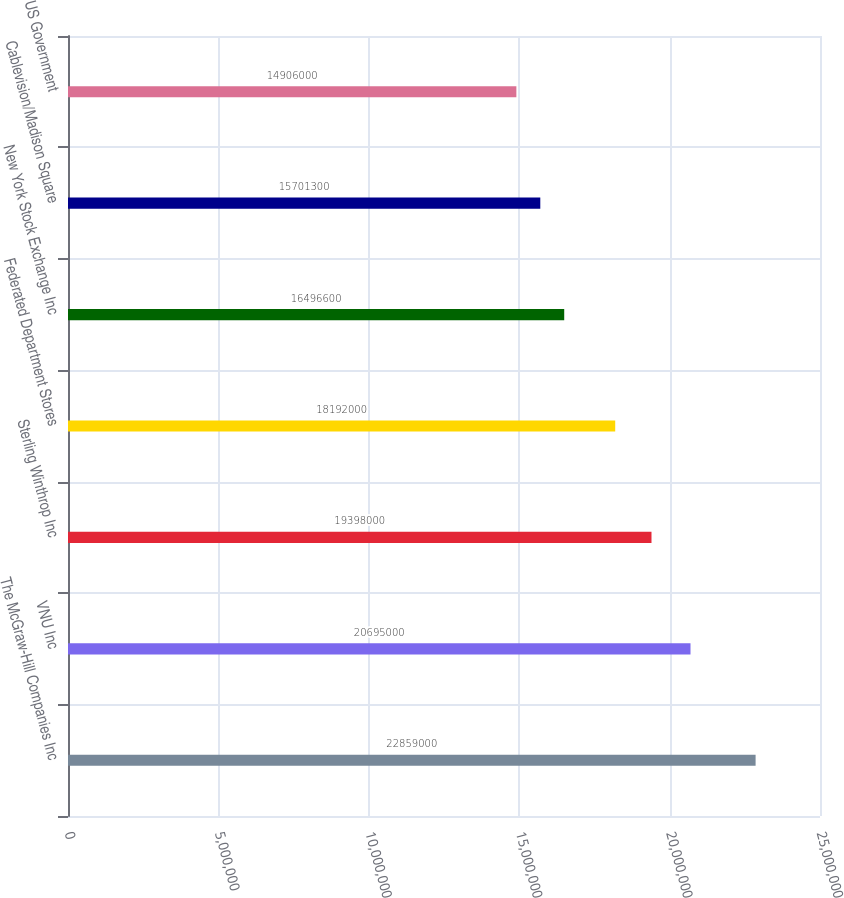<chart> <loc_0><loc_0><loc_500><loc_500><bar_chart><fcel>The McGraw-Hill Companies Inc<fcel>VNU Inc<fcel>Sterling Winthrop Inc<fcel>Federated Department Stores<fcel>New York Stock Exchange Inc<fcel>Cablevision/Madison Square<fcel>US Government<nl><fcel>2.2859e+07<fcel>2.0695e+07<fcel>1.9398e+07<fcel>1.8192e+07<fcel>1.64966e+07<fcel>1.57013e+07<fcel>1.4906e+07<nl></chart> 